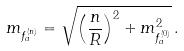<formula> <loc_0><loc_0><loc_500><loc_500>m _ { f ^ { ( n ) } _ { a } } = \sqrt { \left ( \frac { n } { R } \right ) ^ { 2 } + m ^ { 2 } _ { f ^ { ( 0 ) } _ { a } } } \, .</formula> 